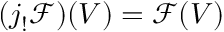<formula> <loc_0><loc_0><loc_500><loc_500>( j _ { ! } { \mathcal { F } } ) ( V ) = { \mathcal { F } } ( V )</formula> 